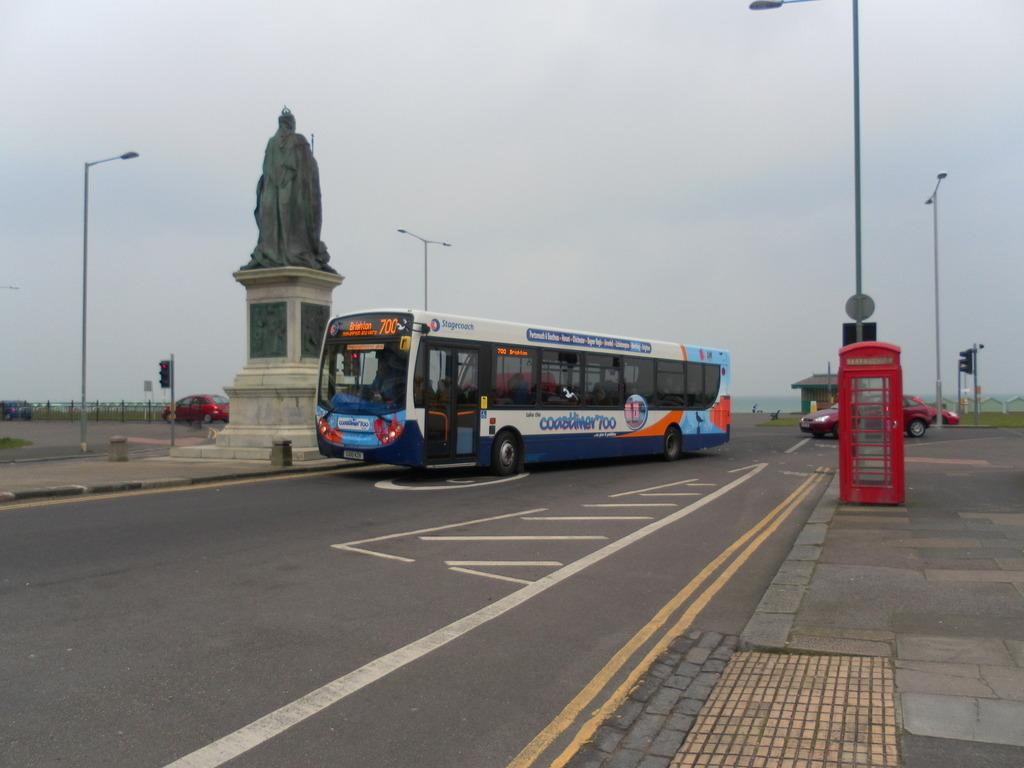What is the main subject of the image? The main subject of the image is a bus moving on the road. Can you describe the road in the image? The road has white and blue colors. What is located beside the bus? There is a statue beside the bus. How would you describe the sky in the image? The sky is cloudy in the image. What type of argument can be heard between the band members in the image? There is no band or argument present in the image; it features a bus moving on a road with a statue beside it. Can you see a robin perched on the bus in the image? There is no robin present in the image. 